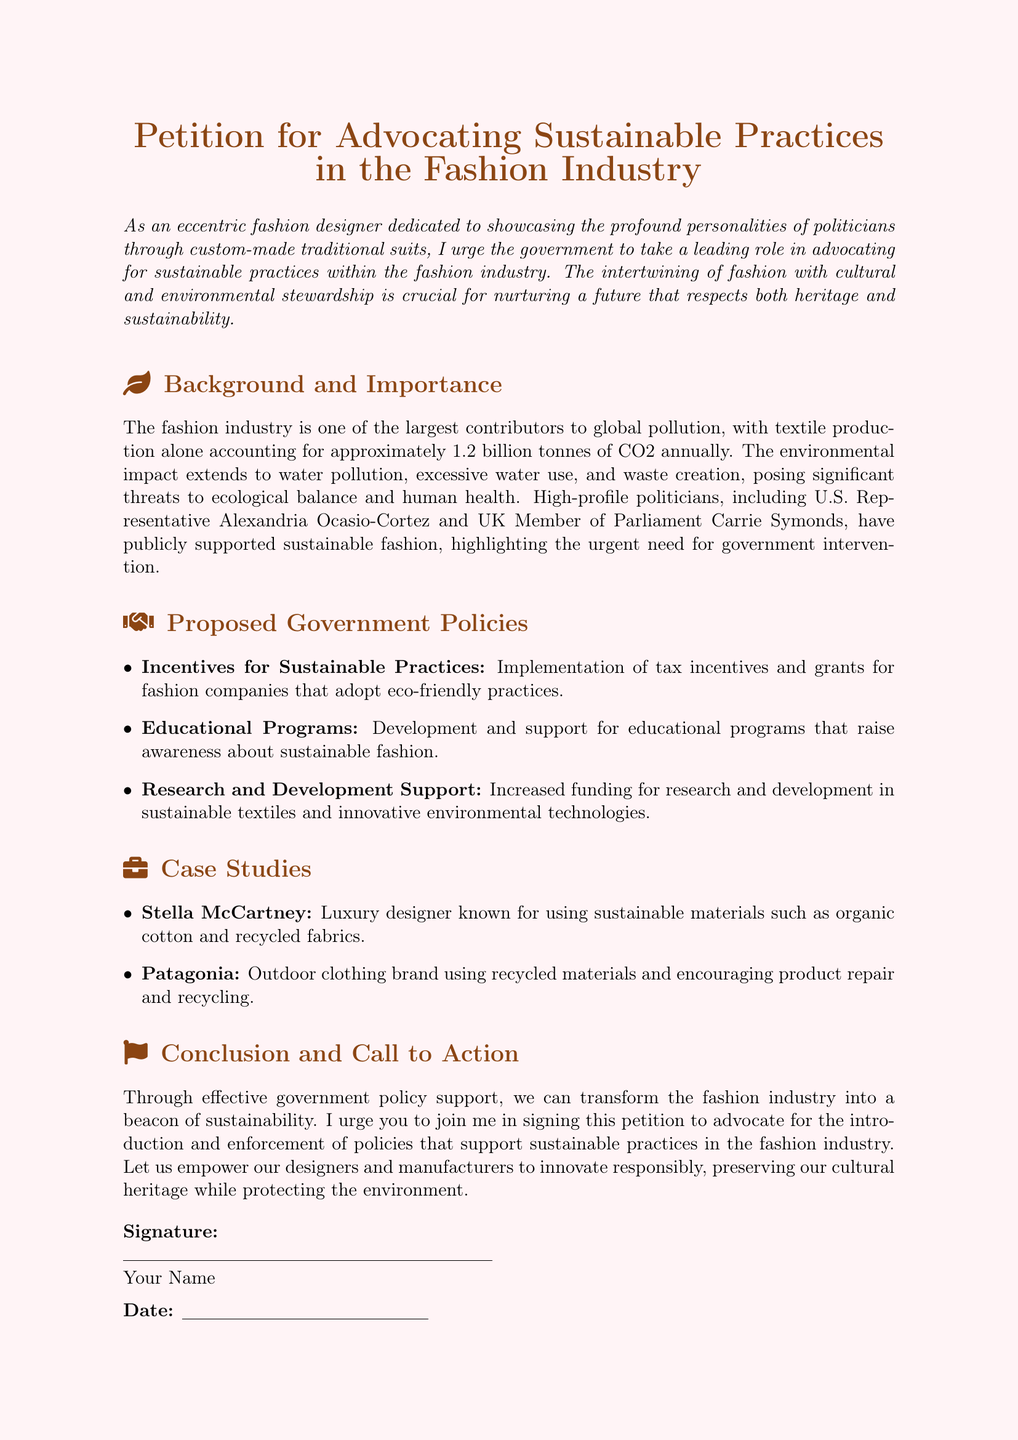What is the title of the petition? The title outlines the primary focus of the document, which is about advocating for sustainable practices in the fashion industry.
Answer: Petition for Advocating Sustainable Practices in the Fashion Industry How much CO2 is produced annually by textile production? The document specifies the annual CO2 production attributed to textile production, highlighting the environmental impact.
Answer: 1.2 billion tonnes Who are the two politicians mentioned as supporters of sustainable fashion? The document lists high-profile politicians who have shown support for sustainable fashion, which includes notable figures.
Answer: Alexandria Ocasio-Cortez and Carrie Symonds What type of programs does the petition propose to develop? The petition suggests a specific type of program aimed at raising awareness and education regarding sustainable practices.
Answer: Educational Programs What company is known for using organic cotton and recycled fabrics? The document provides an example of a luxury designer who focuses on sustainable materials.
Answer: Stella McCartney What is one proposed government policy mentioned in the petition? The document lists several strategies for encouraging sustainable practices in the fashion industry, focusing on policy suggestions.
Answer: Incentives for Sustainable Practices What does the petition urge people to join in signing? The document culminates in a call to action, emphasizing the importance of gaining support for a particular initiative.
Answer: This petition When should the signature be dated? The document includes a place for the signer to date their signature, which is part of its structure.
Answer: Date 